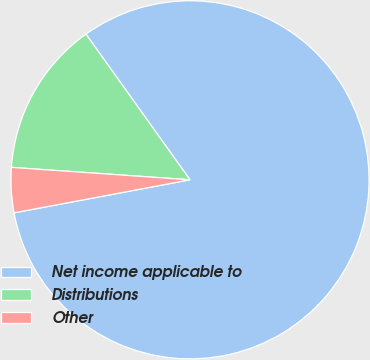<chart> <loc_0><loc_0><loc_500><loc_500><pie_chart><fcel>Net income applicable to<fcel>Distributions<fcel>Other<nl><fcel>81.92%<fcel>14.02%<fcel>4.06%<nl></chart> 